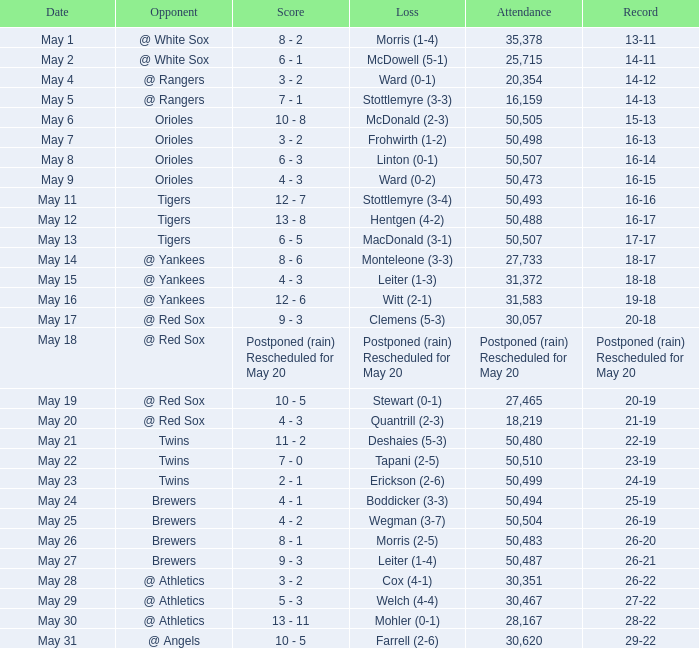What team did they lose to when they had a 28-22 record? Mohler (0-1). 